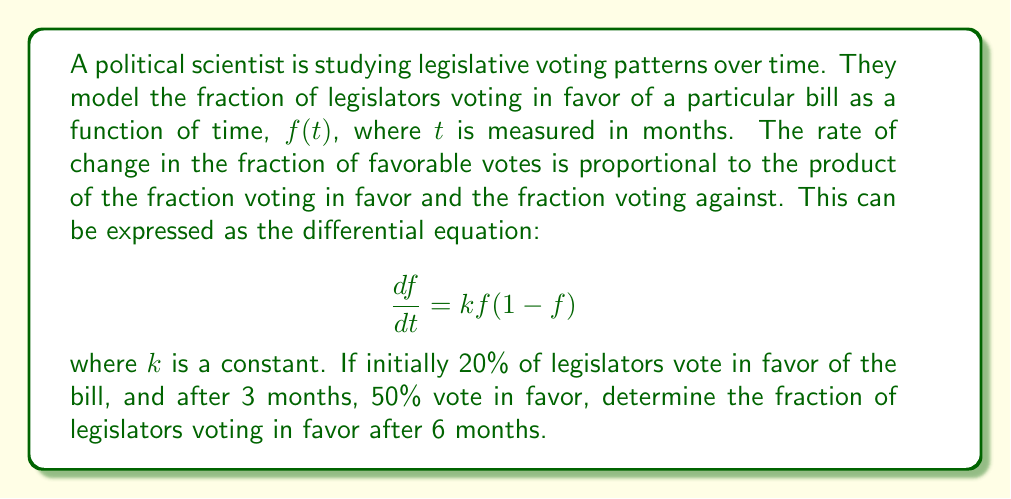Show me your answer to this math problem. To solve this problem, we need to follow these steps:

1) First, we need to solve the differential equation:
   $$\frac{df}{dt} = kf(1-f)$$
   This is a separable equation. We can rewrite it as:
   $$\frac{df}{f(1-f)} = k dt$$

2) Integrating both sides:
   $$\int \frac{df}{f(1-f)} = \int k dt$$
   $$\ln|\frac{f}{1-f}| = kt + C$$

3) Solving for $f$:
   $$\frac{f}{1-f} = e^{kt+C} = Ae^{kt}$$, where $A = e^C$
   $$f = \frac{Ae^{kt}}{1+Ae^{kt}}$$

4) Now we can use the initial condition: At $t=0$, $f(0) = 0.2$
   $$0.2 = \frac{A}{1+A}$$
   $$A = \frac{0.2}{0.8} = 0.25$$

5) We can now use the condition at 3 months to find $k$:
   $$0.5 = \frac{0.25e^{3k}}{1+0.25e^{3k}}$$
   Solving this equation:
   $$e^{3k} = 3$$
   $$k = \frac{\ln 3}{3} \approx 0.3662$$

6) Now we have the complete solution:
   $$f(t) = \frac{0.25e^{0.3662t}}{1+0.25e^{0.3662t}}$$

7) To find the fraction voting in favor after 6 months, we substitute $t=6$:
   $$f(6) = \frac{0.25e^{0.3662 * 6}}{1+0.25e^{0.3662 * 6}} \approx 0.7311$$
Answer: After 6 months, approximately 73.11% of legislators will vote in favor of the bill. 